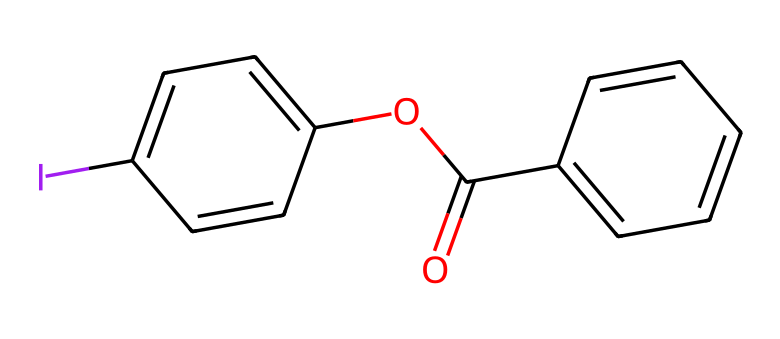What is the total number of carbon atoms in the structure? By analyzing the SMILES representation, we can see instances of 'C', indicating carbon atoms. Counting the 'C's yields a total of 12 carbon atoms.
Answer: 12 How many oxygen atoms are present in this chemical structure? The SMILES representation contains two instances of 'O', indicating the presence of two oxygen atoms.
Answer: 2 What type of hybridization is most likely present in the iodine atom of this compound? Considering iodine's ability to expand its octet and form multiple bonds, it is likely to have sp3d hybridization in this hypervalent structure.
Answer: sp3d What functional groups are present in this compound? The structure shows both an aromatic ring system and an ester functional group, identified by the sequences C(=O)O, indicating an ester link.
Answer: ester and aromatic Which part of the compound indicates its application in LCD screen manufacturing? The aromatic rings and the presence of iodine in the structure suggest it may serve as a photoactive component in LCD manufacturing, which commonly uses such compounds for achieving desired optical properties.
Answer: photoactive component How many double bonds can be identified in the structure? By examining the representation, we identify three instances of double bonds formed by C=C connections and one double bond in the C=O functional group in the ester, totaling four double bonds.
Answer: 4 Is iodine acting as a Lewis acid or a Lewis base here? Iodine in this hypervalent compound typically acts as a Lewis acid, accepting electron pairs due to its capability to expand its valence shell.
Answer: Lewis acid 